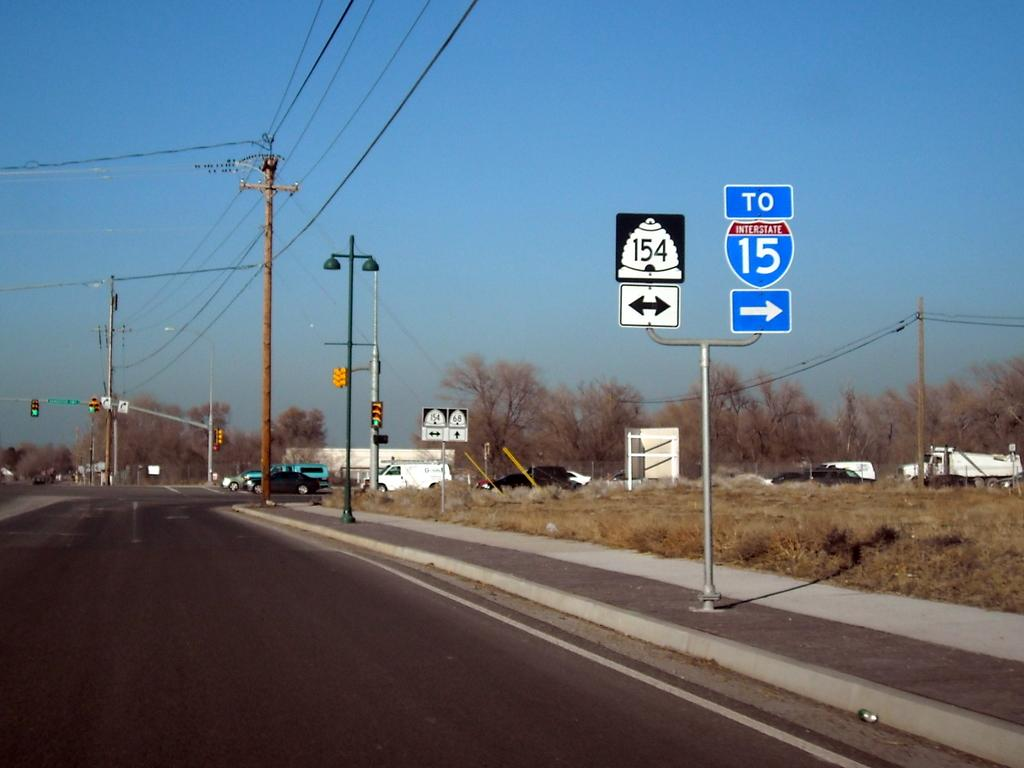Provide a one-sentence caption for the provided image. A highway has a sign that says To Interstate 15. 